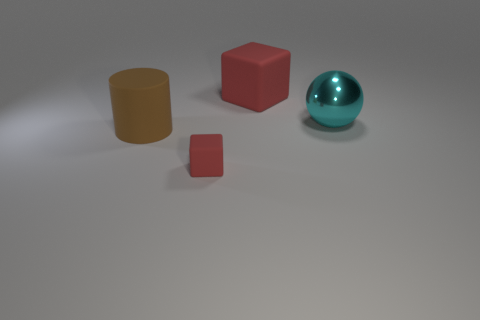Is the number of large balls less than the number of red rubber cubes?
Offer a terse response. Yes. There is a tiny red matte thing that is in front of the ball; is it the same shape as the brown object?
Provide a succinct answer. No. Are any tiny gray shiny cubes visible?
Provide a short and direct response. No. There is a big matte object that is left of the red cube in front of the big rubber object behind the matte cylinder; what color is it?
Your answer should be compact. Brown. Is the number of large rubber cylinders that are on the right side of the small thing the same as the number of brown cylinders right of the large sphere?
Offer a terse response. Yes. What is the shape of the cyan metallic object that is the same size as the rubber cylinder?
Keep it short and to the point. Sphere. Are there any large cubes that have the same color as the tiny matte thing?
Make the answer very short. Yes. What shape is the red object in front of the big red block?
Offer a terse response. Cube. The big cube has what color?
Give a very brief answer. Red. There is a cylinder that is the same material as the small thing; what is its color?
Your answer should be compact. Brown. 